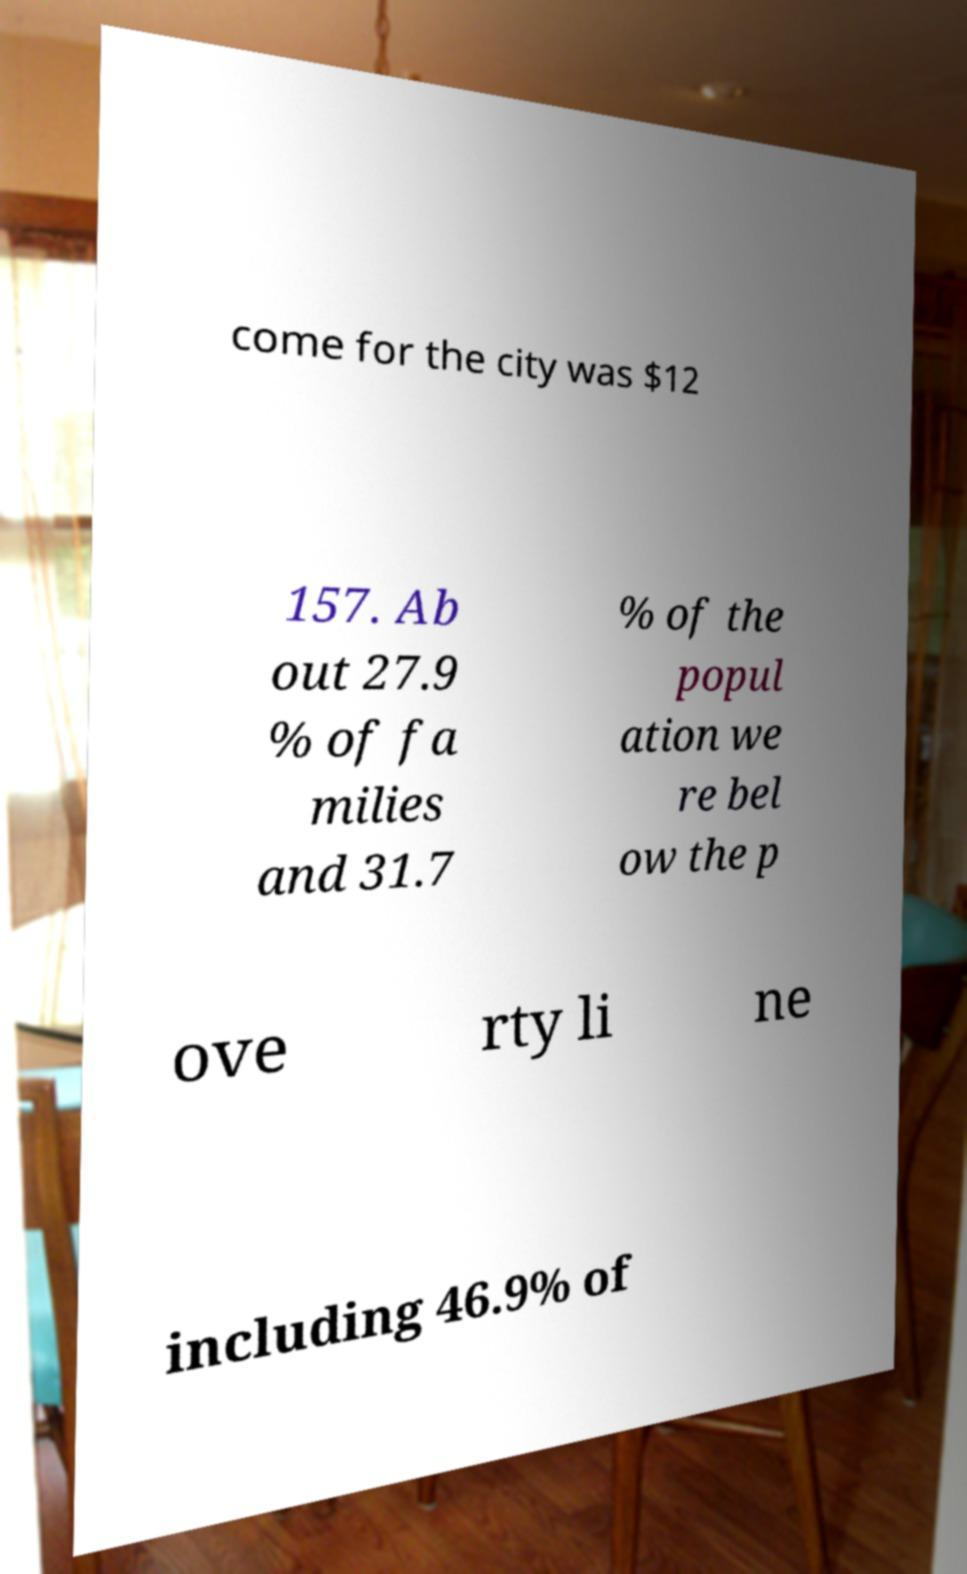Please identify and transcribe the text found in this image. come for the city was $12 157. Ab out 27.9 % of fa milies and 31.7 % of the popul ation we re bel ow the p ove rty li ne including 46.9% of 